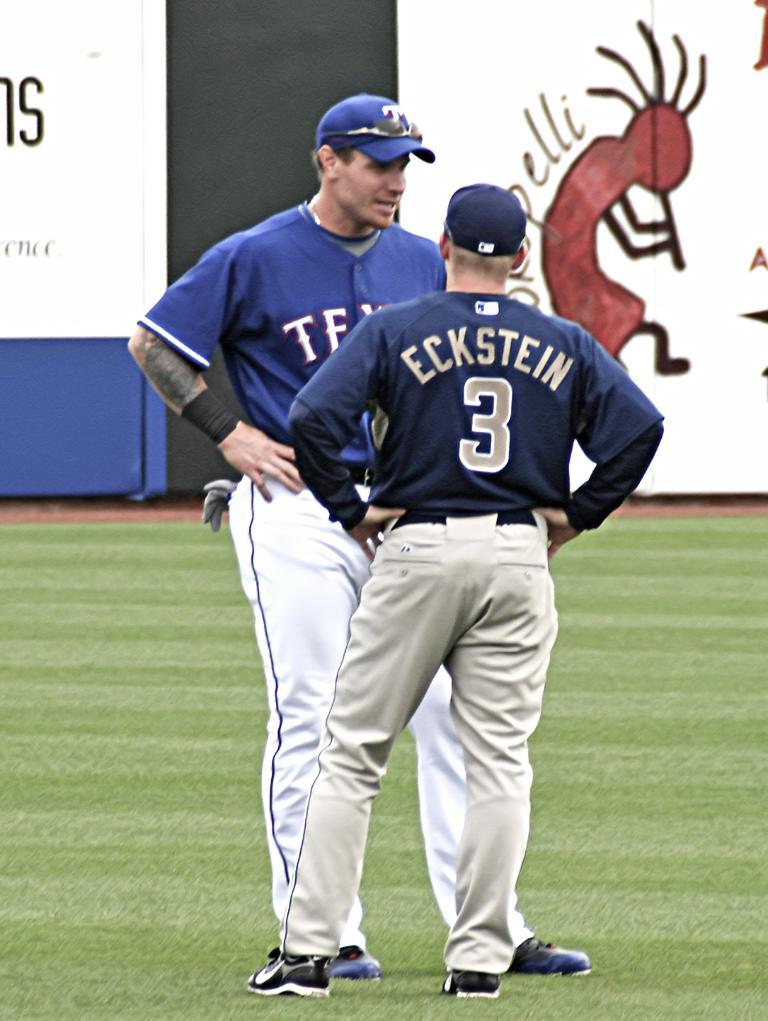<image>
Give a short and clear explanation of the subsequent image. a couple of baseball players with the number 3 on it 